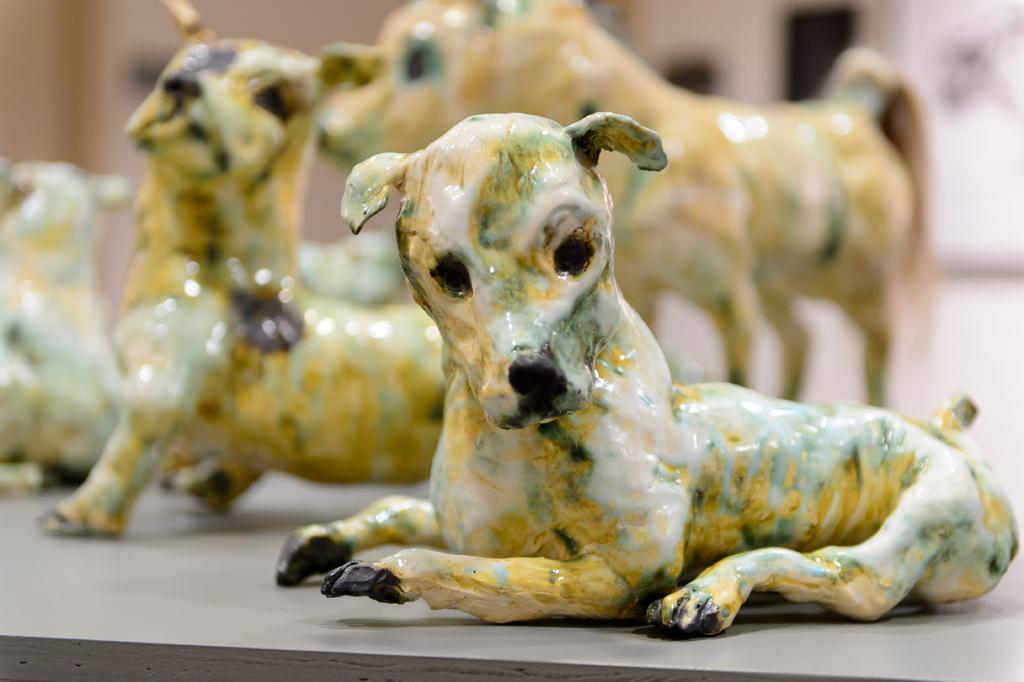What type of objects are present in the image? There are ceramic animals in the image. What piece of furniture can be seen in the image? There is a table in the image. Can you describe the quality of the image? The image is blurry at the back. What type of scent can be detected from the ceramic animals in the image? Ceramic animals do not emit scents, so it is not possible to detect a scent from them in the image. 